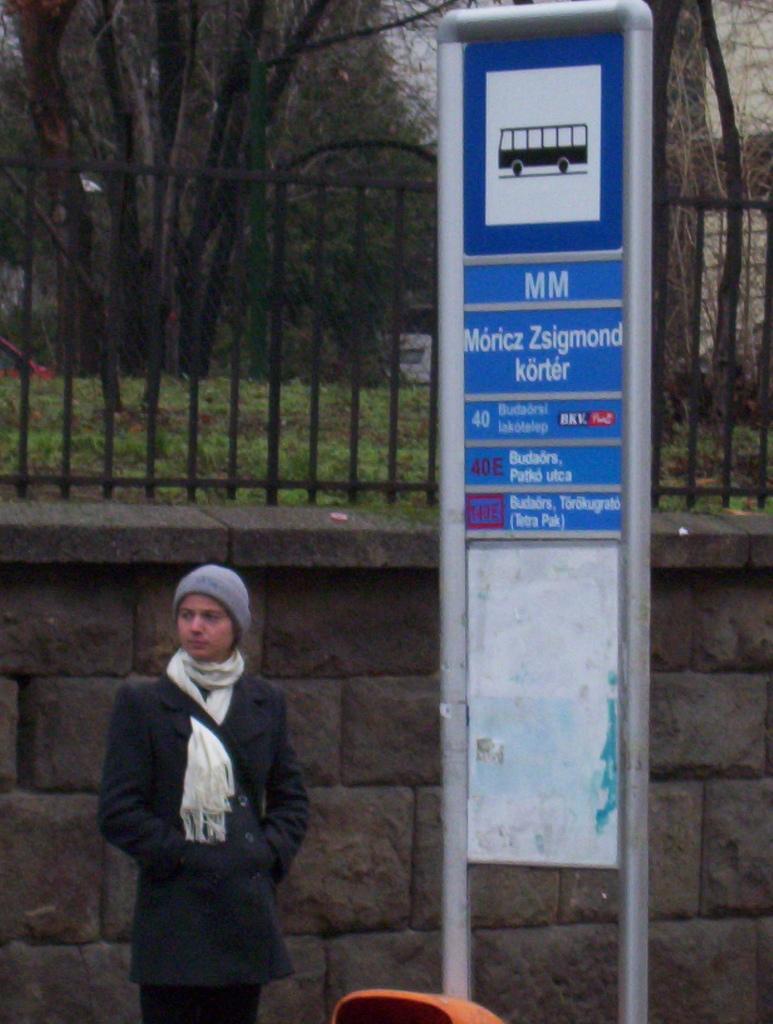Could you give a brief overview of what you see in this image? In this image on the left side there is one person who is standing, and on the right side are there is one board. On the board there is some text and in the background there is a fence and some trees, and in the center there is a wall. 